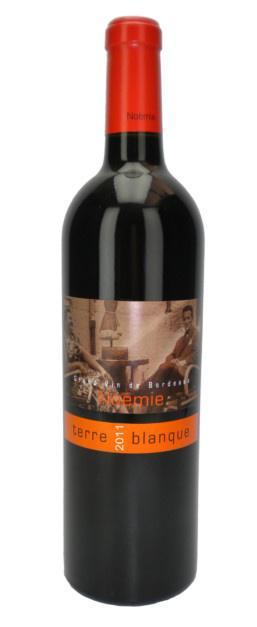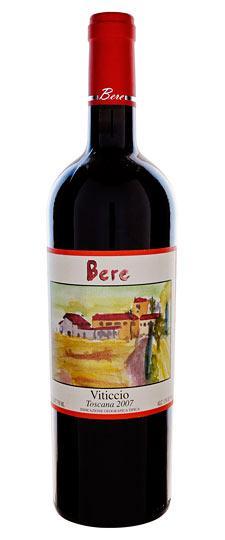The first image is the image on the left, the second image is the image on the right. Examine the images to the left and right. Is the description "wine bottles with a white background" accurate? Answer yes or no. Yes. The first image is the image on the left, the second image is the image on the right. Assess this claim about the two images: "At least one of the images shows a sealed bottle of wine.". Correct or not? Answer yes or no. Yes. 